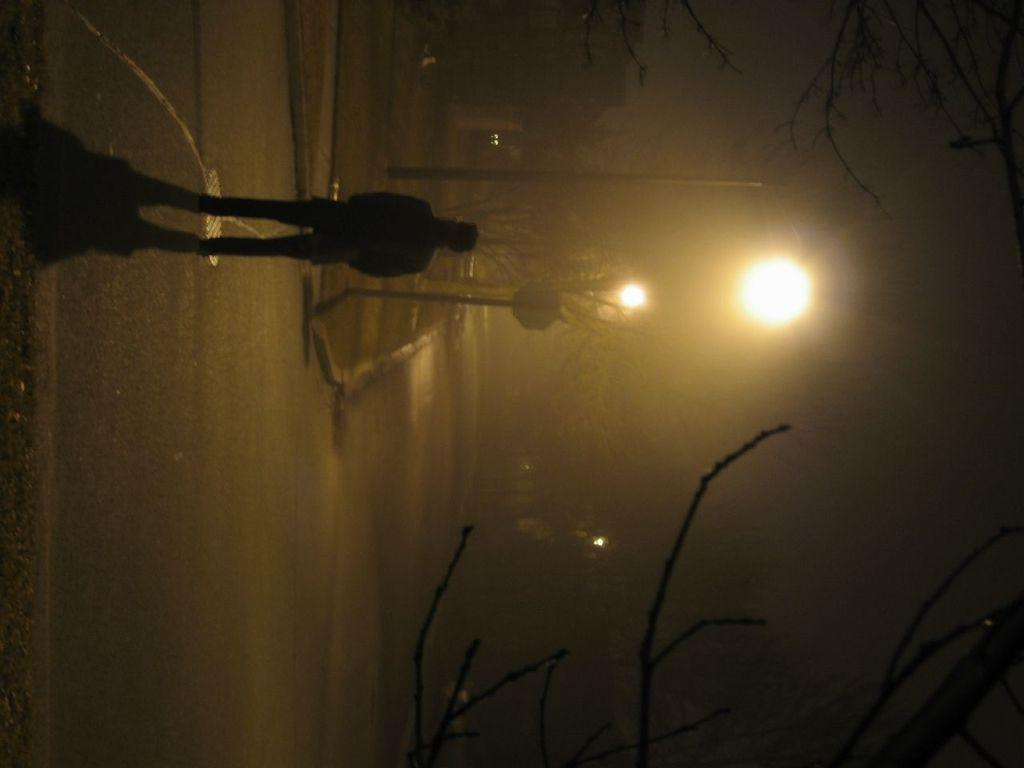What is the person in the image doing? The person is standing on the road. What can be seen in the background of the image? There are poles, a sign board, lights, and trees in the background of the image. How long does it take for the can to be filled with yard in the image? There is no can or yard present in the image, so this question cannot be answered. 